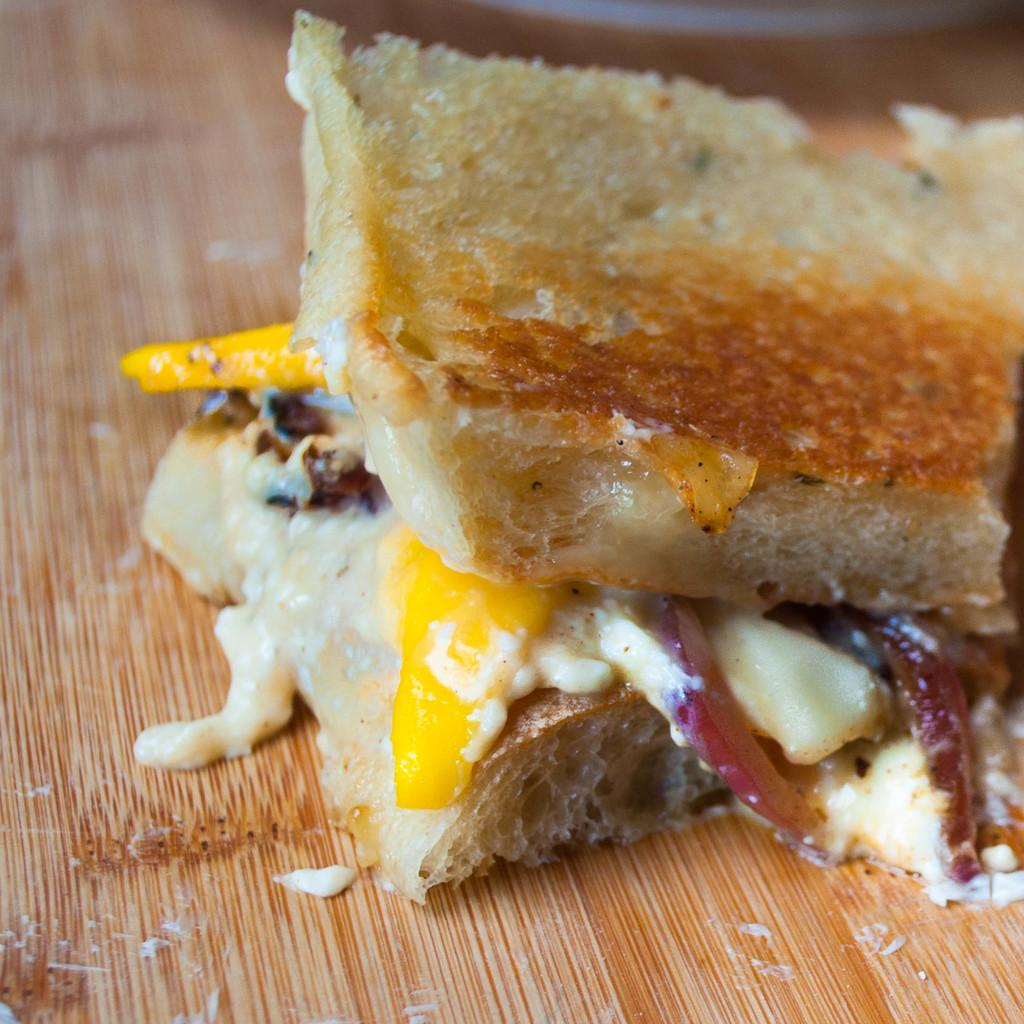What is the main subject of the image? There is a food item in the image. Can you describe the surface on which the food item is placed? The food item is on a wooden surface. Reasoning: Leting: Let's think step by step in order to produce the conversation. We start by identifying the main subject of the image, which is the food item. Then, we describe the surface on which the food item is placed, providing additional context about the image. We avoid yes/no questions and ensure that the language is simple and clear. Absurd Question/Answer: What type of steel is used to construct the control panel in the image? There is no control panel or steel present in the image; it features a food item on a wooden surface. What is the end goal of the control panel in the image? There is no control panel present in the image; it features a food item on a wooden surface. 